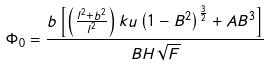<formula> <loc_0><loc_0><loc_500><loc_500>\Phi _ { 0 } = \frac { b \left [ \left ( \frac { l ^ { 2 } + b ^ { 2 } } { l ^ { 2 } } \right ) k u \left ( 1 - B ^ { 2 } \right ) ^ { \frac { 3 } { 2 } } + A B ^ { 3 } \right ] } { B H \sqrt { F } }</formula> 